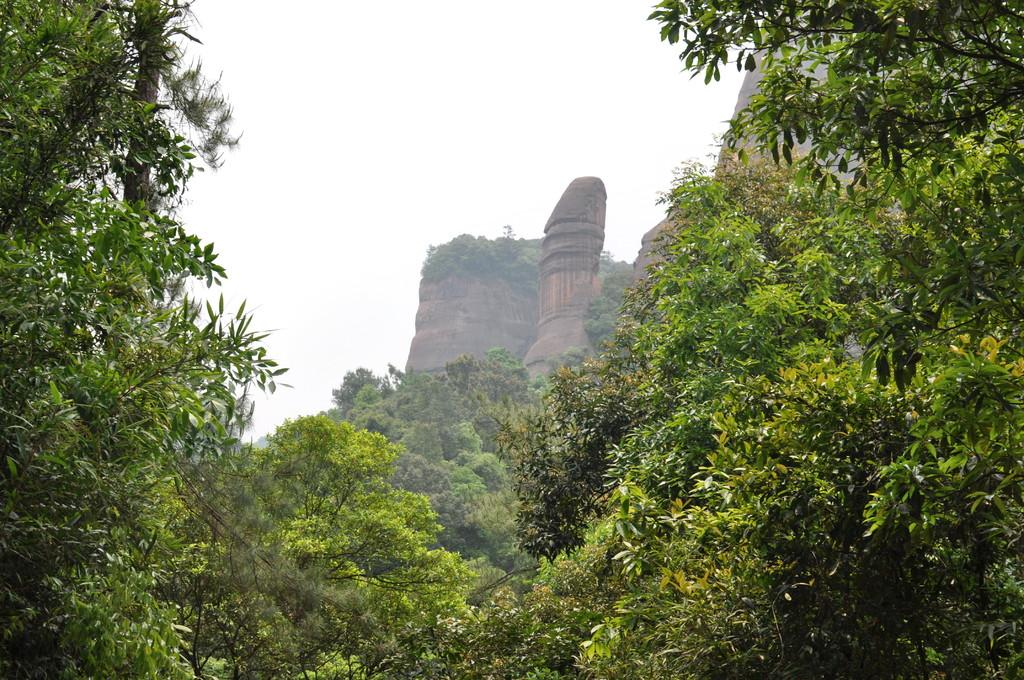What type of vegetation can be seen in the image? There are trees in the image. What type of geographical feature is present in the image? There are hills in the image. What is visible in the background of the image? The sky is visible in the image. What type of bread can be seen smashed on the ground in the image? There is no bread or any indication of smashing in the image; it features trees and hills with a visible sky. 